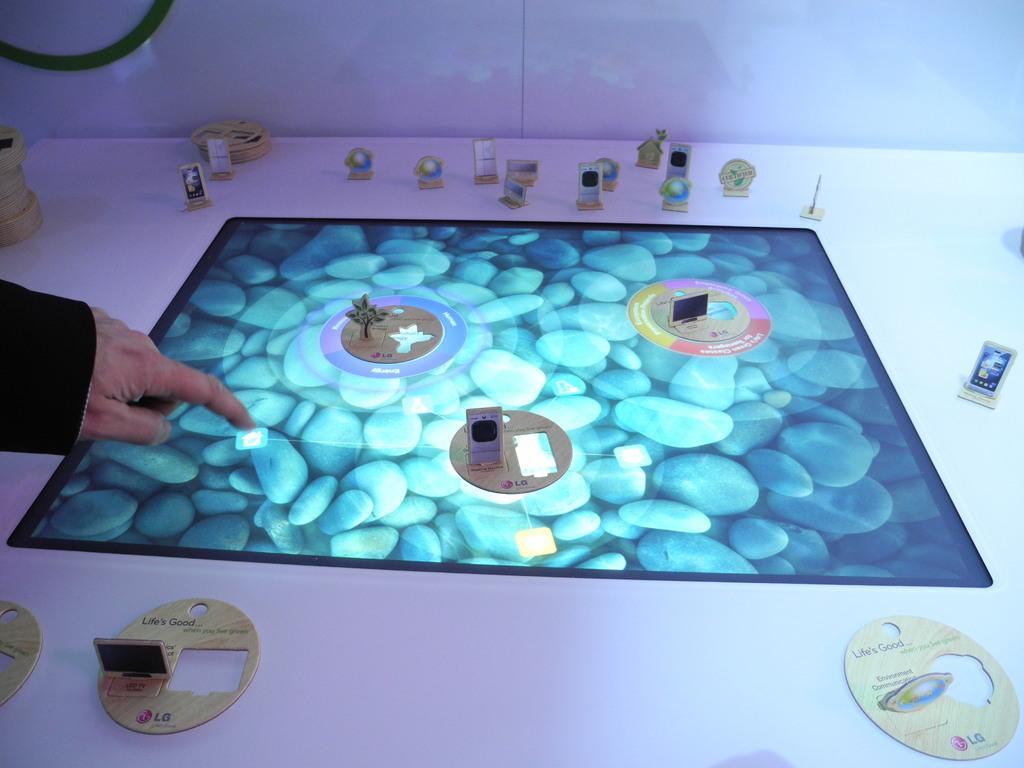Could you give a brief overview of what you see in this image? In this image in the center there is a screen. On the screen there are objects and on the left side there is a hand of the person. In the background on the table there are objects. 